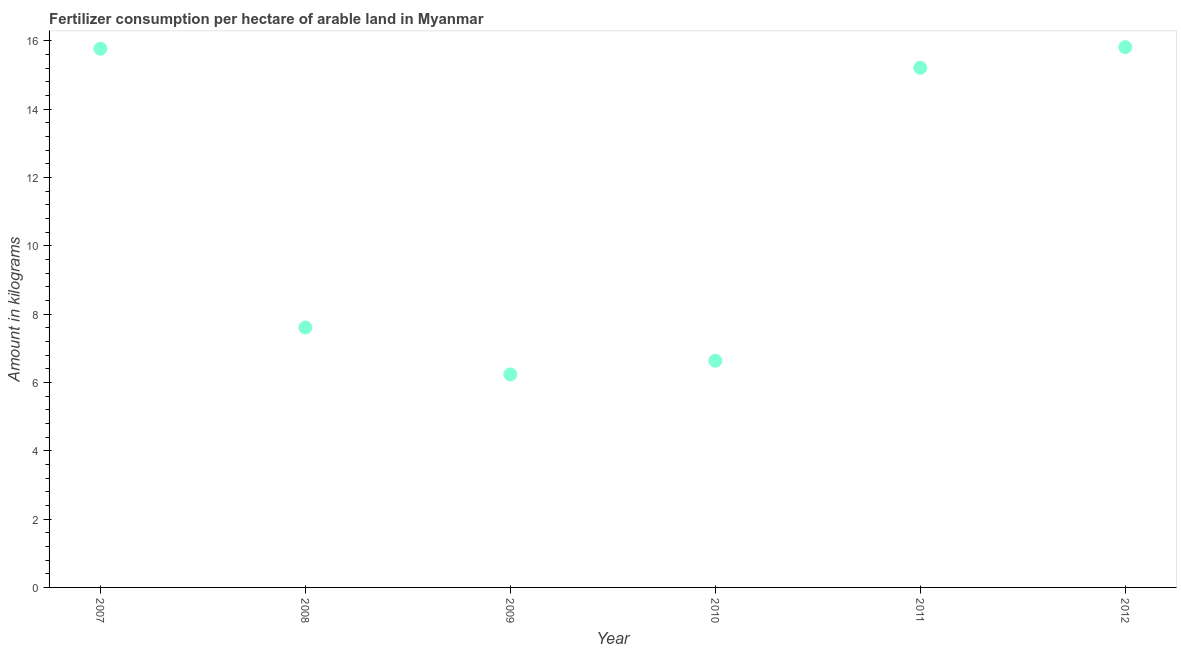What is the amount of fertilizer consumption in 2009?
Provide a short and direct response. 6.24. Across all years, what is the maximum amount of fertilizer consumption?
Your answer should be compact. 15.82. Across all years, what is the minimum amount of fertilizer consumption?
Provide a succinct answer. 6.24. In which year was the amount of fertilizer consumption maximum?
Keep it short and to the point. 2012. In which year was the amount of fertilizer consumption minimum?
Your response must be concise. 2009. What is the sum of the amount of fertilizer consumption?
Offer a very short reply. 67.29. What is the difference between the amount of fertilizer consumption in 2007 and 2008?
Give a very brief answer. 8.16. What is the average amount of fertilizer consumption per year?
Offer a terse response. 11.22. What is the median amount of fertilizer consumption?
Offer a terse response. 11.41. In how many years, is the amount of fertilizer consumption greater than 7.6 kg?
Your response must be concise. 4. What is the ratio of the amount of fertilizer consumption in 2007 to that in 2011?
Make the answer very short. 1.04. Is the difference between the amount of fertilizer consumption in 2007 and 2011 greater than the difference between any two years?
Offer a terse response. No. What is the difference between the highest and the second highest amount of fertilizer consumption?
Ensure brevity in your answer.  0.05. What is the difference between the highest and the lowest amount of fertilizer consumption?
Your answer should be very brief. 9.58. How many dotlines are there?
Give a very brief answer. 1. What is the difference between two consecutive major ticks on the Y-axis?
Your answer should be very brief. 2. Are the values on the major ticks of Y-axis written in scientific E-notation?
Your answer should be compact. No. Does the graph contain grids?
Offer a very short reply. No. What is the title of the graph?
Make the answer very short. Fertilizer consumption per hectare of arable land in Myanmar . What is the label or title of the Y-axis?
Your answer should be compact. Amount in kilograms. What is the Amount in kilograms in 2007?
Keep it short and to the point. 15.77. What is the Amount in kilograms in 2008?
Give a very brief answer. 7.61. What is the Amount in kilograms in 2009?
Provide a succinct answer. 6.24. What is the Amount in kilograms in 2010?
Keep it short and to the point. 6.64. What is the Amount in kilograms in 2011?
Offer a terse response. 15.22. What is the Amount in kilograms in 2012?
Offer a very short reply. 15.82. What is the difference between the Amount in kilograms in 2007 and 2008?
Your answer should be compact. 8.16. What is the difference between the Amount in kilograms in 2007 and 2009?
Your response must be concise. 9.54. What is the difference between the Amount in kilograms in 2007 and 2010?
Keep it short and to the point. 9.14. What is the difference between the Amount in kilograms in 2007 and 2011?
Make the answer very short. 0.56. What is the difference between the Amount in kilograms in 2007 and 2012?
Keep it short and to the point. -0.05. What is the difference between the Amount in kilograms in 2008 and 2009?
Keep it short and to the point. 1.37. What is the difference between the Amount in kilograms in 2008 and 2010?
Ensure brevity in your answer.  0.97. What is the difference between the Amount in kilograms in 2008 and 2011?
Keep it short and to the point. -7.61. What is the difference between the Amount in kilograms in 2008 and 2012?
Offer a very short reply. -8.21. What is the difference between the Amount in kilograms in 2009 and 2010?
Your answer should be very brief. -0.4. What is the difference between the Amount in kilograms in 2009 and 2011?
Provide a succinct answer. -8.98. What is the difference between the Amount in kilograms in 2009 and 2012?
Give a very brief answer. -9.58. What is the difference between the Amount in kilograms in 2010 and 2011?
Give a very brief answer. -8.58. What is the difference between the Amount in kilograms in 2010 and 2012?
Your answer should be compact. -9.18. What is the difference between the Amount in kilograms in 2011 and 2012?
Your answer should be compact. -0.6. What is the ratio of the Amount in kilograms in 2007 to that in 2008?
Give a very brief answer. 2.07. What is the ratio of the Amount in kilograms in 2007 to that in 2009?
Offer a terse response. 2.53. What is the ratio of the Amount in kilograms in 2007 to that in 2010?
Keep it short and to the point. 2.38. What is the ratio of the Amount in kilograms in 2008 to that in 2009?
Give a very brief answer. 1.22. What is the ratio of the Amount in kilograms in 2008 to that in 2010?
Offer a very short reply. 1.15. What is the ratio of the Amount in kilograms in 2008 to that in 2011?
Your answer should be very brief. 0.5. What is the ratio of the Amount in kilograms in 2008 to that in 2012?
Keep it short and to the point. 0.48. What is the ratio of the Amount in kilograms in 2009 to that in 2010?
Your response must be concise. 0.94. What is the ratio of the Amount in kilograms in 2009 to that in 2011?
Your answer should be compact. 0.41. What is the ratio of the Amount in kilograms in 2009 to that in 2012?
Your answer should be compact. 0.39. What is the ratio of the Amount in kilograms in 2010 to that in 2011?
Make the answer very short. 0.44. What is the ratio of the Amount in kilograms in 2010 to that in 2012?
Offer a very short reply. 0.42. 